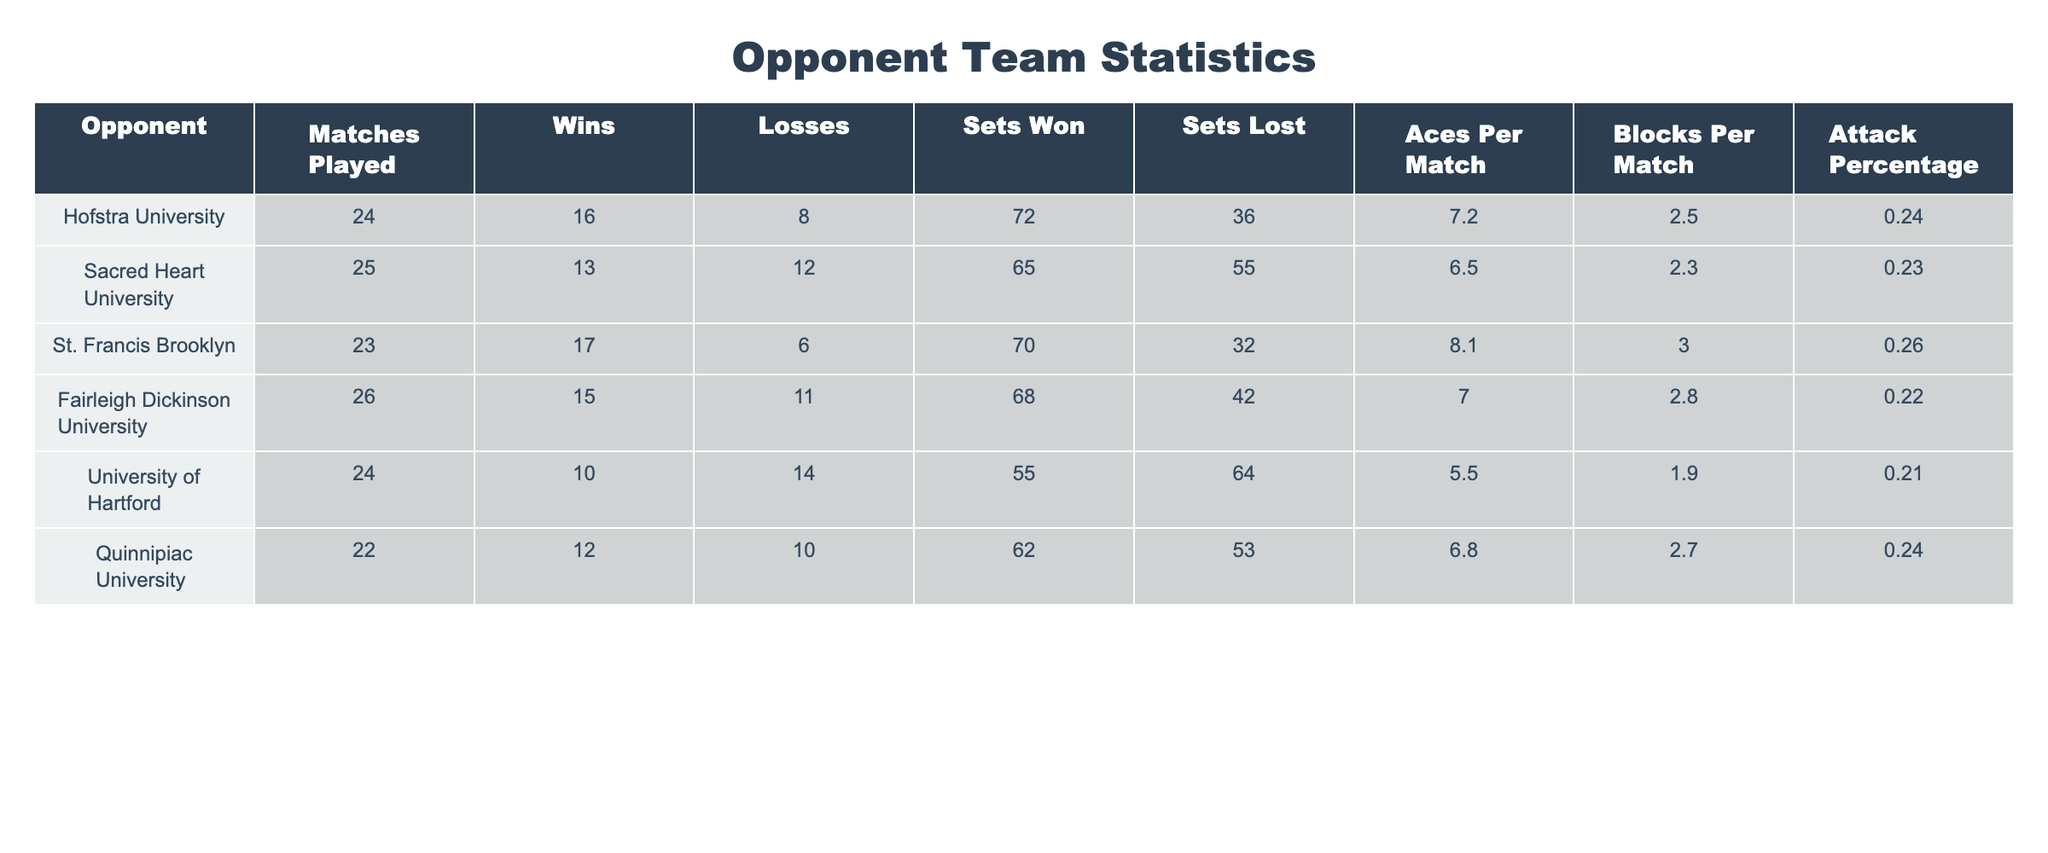What is the team with the highest number of wins? By checking the "Wins" column, we can see that St. Francis Brooklyn has 17 wins, which is the highest among all the teams listed.
Answer: St. Francis Brooklyn How many sets has Fairleigh Dickinson University won? Referring to the "Sets Won" column, Fairleigh Dickinson University has won 68 sets.
Answer: 68 Which team has the lowest attack percentage? Looking at the "Attack Percentage" column, University of Hartford has the lowest percentage at 0.210.
Answer: University of Hartford What is the average number of aces per match among all teams? First, sum the aces per match: 7.2 + 6.5 + 8.1 + 7.0 + 5.5 + 6.8 = 41.1. There are 6 teams, so we divide: 41.1 / 6 = 6.85.
Answer: 6.85 Is it true that Hofstra University has more matches played than Quinnipiac University? Hofstra University played 24 matches, while Quinnipiac University played 22 matches. Thus, it is true that Hofstra University has more matches played.
Answer: Yes Which team has the highest average blocks per match and what is the value? The "Blocks Per Match" column shows that St. Francis Brooklyn has the highest average at 3.0.
Answer: St. Francis Brooklyn, 3.0 If we compare the total sets won and lost for Sacred Heart University, what is the difference? Sacred Heart University won 65 sets and lost 55 sets. The difference is calculated as 65 - 55 = 10.
Answer: 10 Which team has the highest ratio of sets won to matches played? To find the ratio, divide the sets won by matches played for each team. For St. Francis Brooklyn: 70/23 ≈ 3.04. No other team exceeds this ratio when calculated.
Answer: St. Francis Brooklyn What percentage of matches has the University of Hartford won? The University of Hartford has won 10 matches out of 24. The win percentage is calculated as (10 / 24) * 100 = 41.67%.
Answer: 41.67% What is the overall average number of blocks per match across all teams? First, sum the blocks per match: 2.5 + 2.3 + 3.0 + 2.8 + 1.9 + 2.7 = 15.2. Dividing by the number of teams (6) gives: 15.2 / 6 = 2.53.
Answer: 2.53 